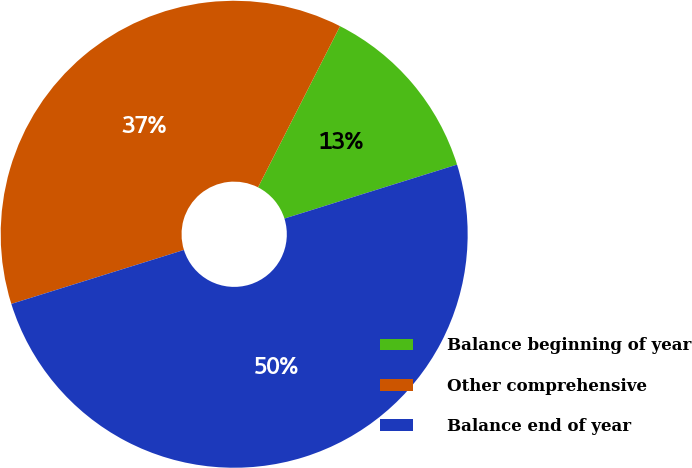Convert chart to OTSL. <chart><loc_0><loc_0><loc_500><loc_500><pie_chart><fcel>Balance beginning of year<fcel>Other comprehensive<fcel>Balance end of year<nl><fcel>12.69%<fcel>37.31%<fcel>50.0%<nl></chart> 